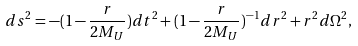<formula> <loc_0><loc_0><loc_500><loc_500>d s ^ { 2 } = - ( 1 - \frac { r } { 2 M _ { U } } ) d t ^ { 2 } + ( 1 - \frac { r } { 2 M _ { U } } ) ^ { - 1 } d r ^ { 2 } + r ^ { 2 } d \Omega ^ { 2 } ,</formula> 